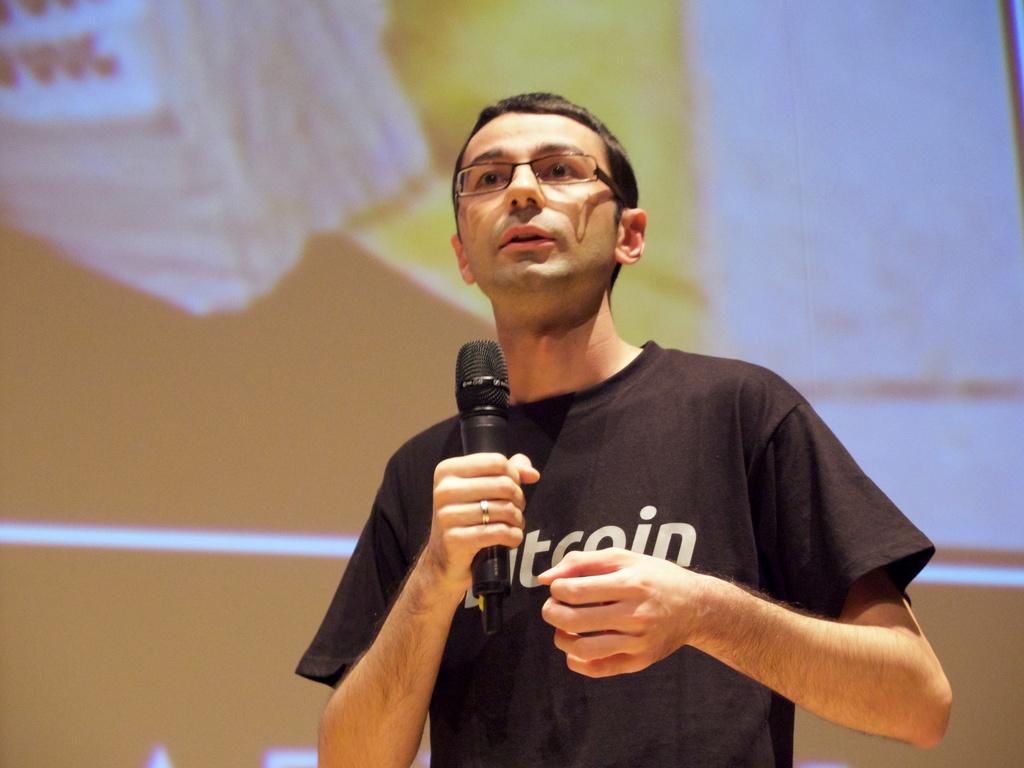Can you describe this image briefly? In this picture we can see a man who is holding a mike with his hand. He has spectacles. And he is in black color t shirt. 